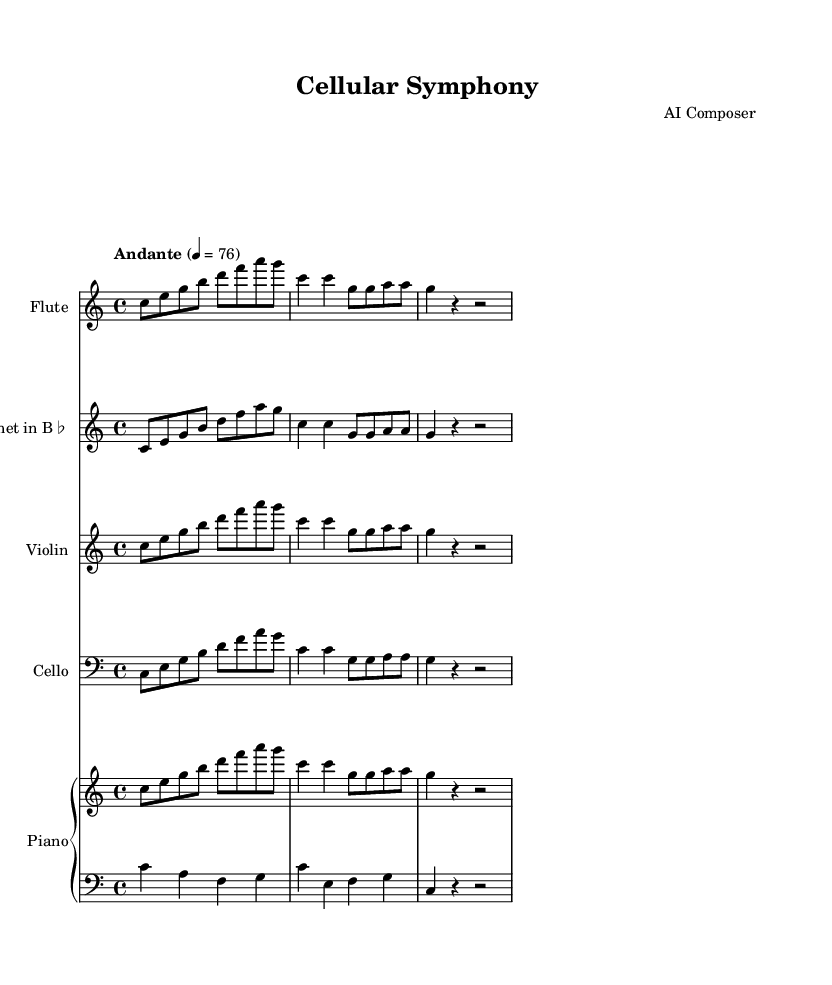What is the title of this composition? The title can be found in the header section of the sheet music. It states "Cellular Symphony."
Answer: Cellular Symphony What is the tempo marking of this piece? The tempo marking is indicated in the global section of the music. It reads "Andante" with a metronome marking of 4 = 76.
Answer: Andante How many measures are in the flute part? By counting the individual sets of bars in the flute part, we see there are four measures in total.
Answer: Four What is the time signature of this music? The time signature is specified in the global section, stating 4/4, which means there are four beats per measure.
Answer: 4/4 Which instrument plays in the bass clef? In the score for cello, the clef is indicated as bass clef, making it the only instrument playing in bass clef.
Answer: Cello What is the key signature key of this composition? The key signature is listed in the global section as C major, which has no sharps or flats.
Answer: C major What instruments are used in this composition? The instruments are listed in the respective staff sections. They include flute, clarinet in B♭, violin, cello, and piano.
Answer: Flute, clarinet in B flat, violin, cello, and piano 